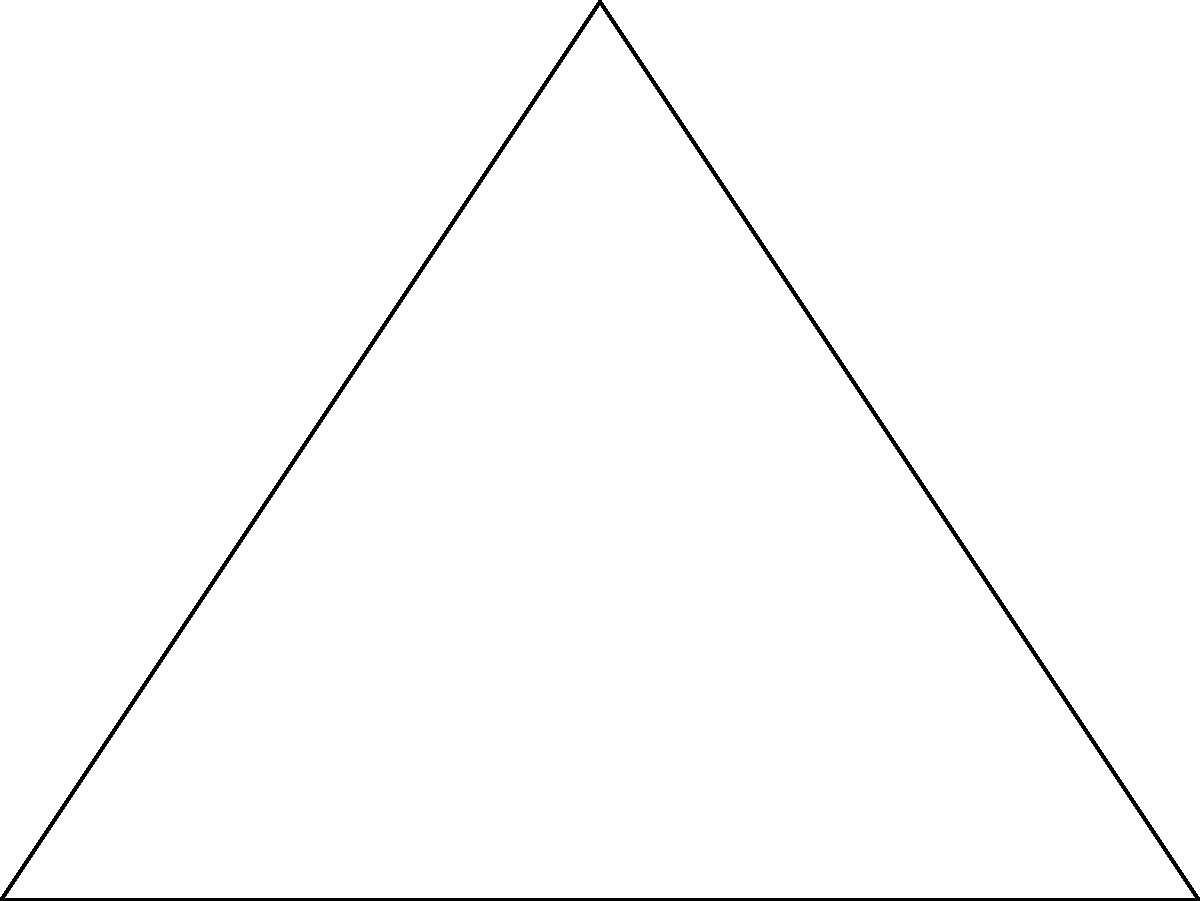In early Christian architecture, dome designs often incorporated principles of circular geometry. Consider a triangular cross-section of a dome with vertices A, B, and C, where O is the center of the circumscribed circle. If the radius of this circle is $r$ and the area of triangle ABC is $6$ square units, what is the value of $r$? To solve this problem, we'll follow these steps:

1) Recall the formula for the area of a triangle using the circumradius:

   $$\text{Area} = \frac{abc}{4R}$$

   where $a$, $b$, and $c$ are the side lengths of the triangle, and $R$ is the circumradius.

2) We're given that the area is 6 square units and the circumradius is $r$. Let's substitute these into the formula:

   $$6 = \frac{abc}{4r}$$

3) Rearrange the equation to isolate $r$:

   $$r = \frac{abc}{24}$$

4) Now, we need to find $a$, $b$, and $c$. In a triangle inscribed in a circle, we can use the formula:

   $$abc = 4R \cdot \text{Area}$$

5) Substituting our known values:

   $$abc = 4r \cdot 6 = 24r$$

6) Now, let's substitute this back into our equation from step 3:

   $$r = \frac{24r}{24} = r$$

7) This identity shows that our solution is consistent, but doesn't give us a specific value for $r$. This means the problem is underdetermined - we need more information to find a unique value for $r$.

8) However, we can conclude that for any triangle with an area of 6 square units, the product of its side lengths will always be $24r$, where $r$ is its circumradius.
Answer: The problem is underdetermined; $r$ cannot be uniquely determined without additional information. 